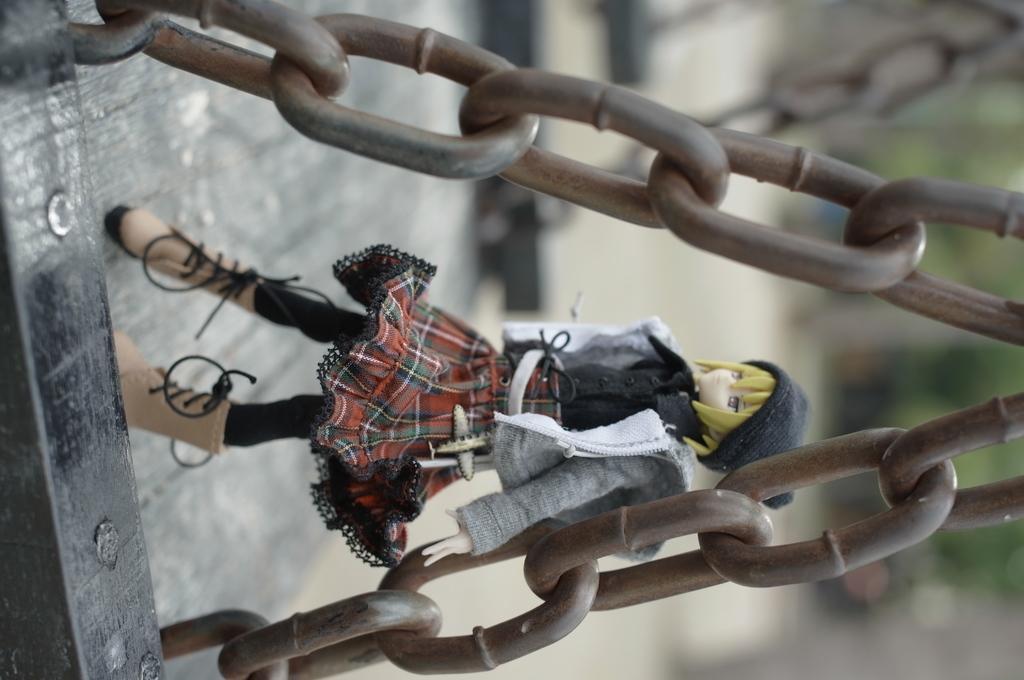Please provide a concise description of this image. In the foreground of the picture we can see chains, a wooden object and toy. Towards right in the background it is blurred. 